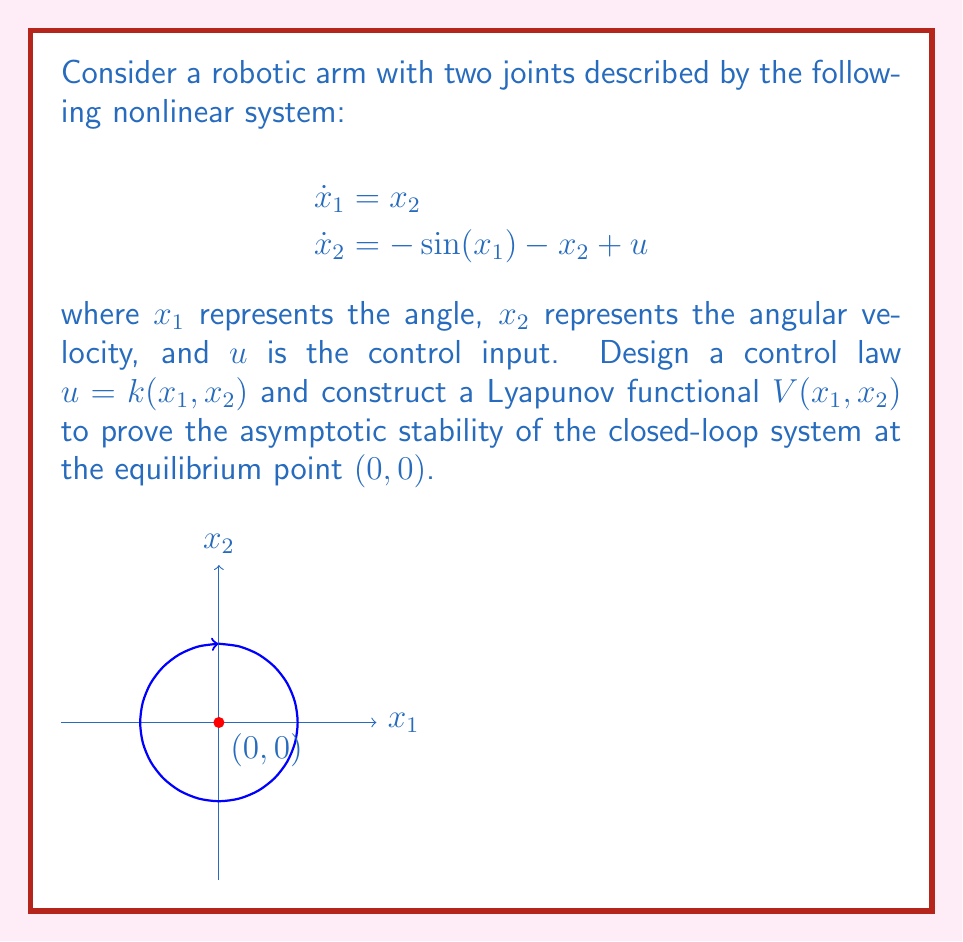What is the answer to this math problem? Let's approach this problem step by step:

1) First, we need to design a control law. A suitable choice would be:

   $u = \sin(x_1) - kx_1 - x_2$

   where $k > 0$ is a positive constant.

2) Substituting this control law into the original system:

   $$
   \begin{aligned}
   \dot{x}_1 &= x_2 \\
   \dot{x}_2 &= -\sin(x_1) - x_2 + (\sin(x_1) - kx_1 - x_2) \\
   &= -kx_1 - 2x_2
   \end{aligned}
   $$

3) Now, let's propose a Lyapunov functional:

   $V(x_1, x_2) = \frac{1}{2}kx_1^2 + \frac{1}{2}x_2^2 + 1 - \cos(x_1)$

4) To prove stability, we need to show that $V > 0$ for all $(x_1, x_2) \neq (0, 0)$ and $\dot{V} < 0$ for all $(x_1, x_2) \neq (0, 0)$.

5) Clearly, $V(0, 0) = 0$ and $V(x_1, x_2) > 0$ for all $(x_1, x_2) \neq (0, 0)$ because $1 - \cos(x_1) \geq 0$ for all $x_1$.

6) Now, let's calculate $\dot{V}$:

   $$
   \begin{aligned}
   \dot{V} &= kx_1\dot{x}_1 + x_2\dot{x}_2 + \sin(x_1)\dot{x}_1 \\
   &= kx_1x_2 + x_2(-kx_1 - 2x_2) + \sin(x_1)x_2 \\
   &= -2x_2^2 < 0
   \end{aligned}
   $$

   for all $(x_1, x_2) \neq (0, 0)$

7) Therefore, by Lyapunov's stability theorem, the system is asymptotically stable at the equilibrium point $(0, 0)$.
Answer: $u = \sin(x_1) - kx_1 - x_2$, $V(x_1, x_2) = \frac{1}{2}kx_1^2 + \frac{1}{2}x_2^2 + 1 - \cos(x_1)$ 